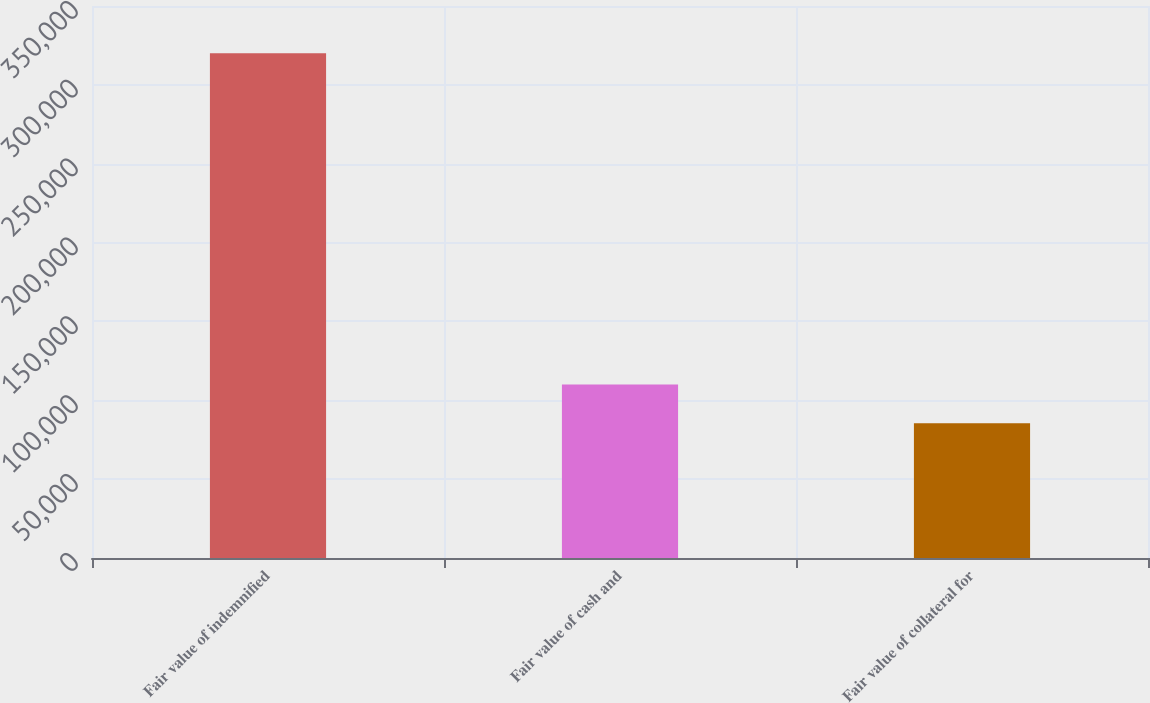<chart> <loc_0><loc_0><loc_500><loc_500><bar_chart><fcel>Fair value of indemnified<fcel>Fair value of cash and<fcel>Fair value of collateral for<nl><fcel>320078<fcel>110010<fcel>85374<nl></chart> 